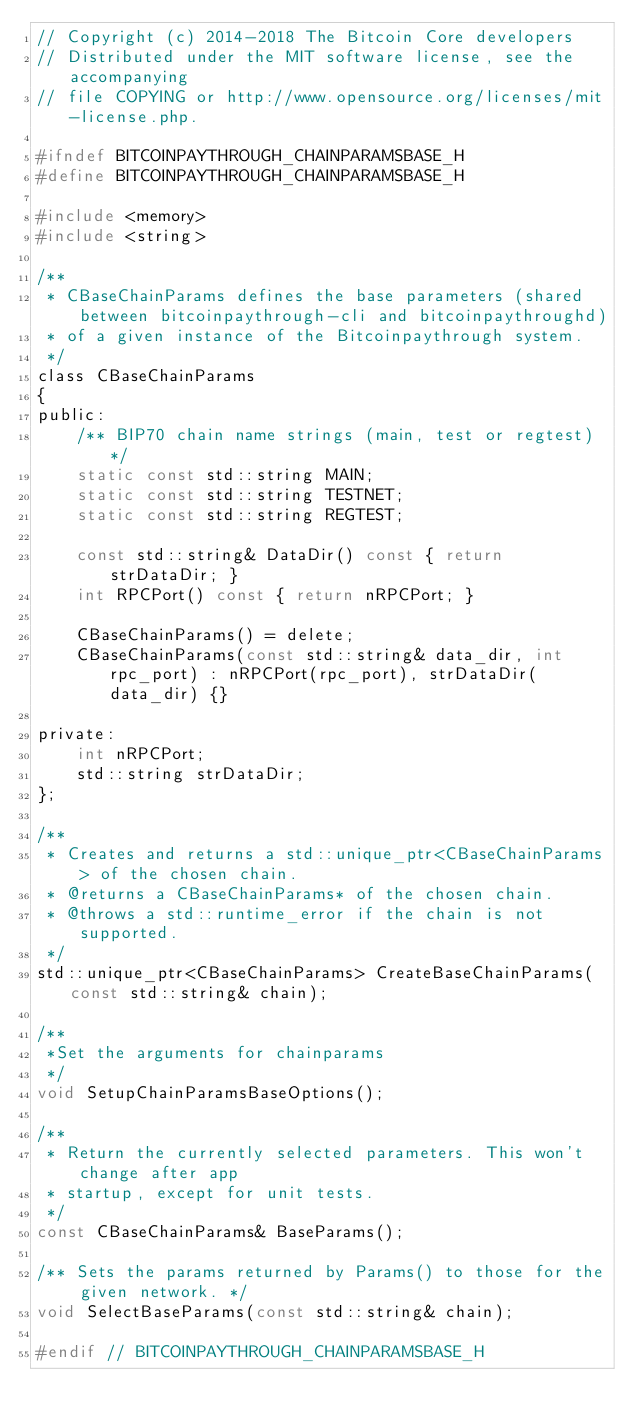Convert code to text. <code><loc_0><loc_0><loc_500><loc_500><_C_>// Copyright (c) 2014-2018 The Bitcoin Core developers
// Distributed under the MIT software license, see the accompanying
// file COPYING or http://www.opensource.org/licenses/mit-license.php.

#ifndef BITCOINPAYTHROUGH_CHAINPARAMSBASE_H
#define BITCOINPAYTHROUGH_CHAINPARAMSBASE_H

#include <memory>
#include <string>

/**
 * CBaseChainParams defines the base parameters (shared between bitcoinpaythrough-cli and bitcoinpaythroughd)
 * of a given instance of the Bitcoinpaythrough system.
 */
class CBaseChainParams
{
public:
    /** BIP70 chain name strings (main, test or regtest) */
    static const std::string MAIN;
    static const std::string TESTNET;
    static const std::string REGTEST;

    const std::string& DataDir() const { return strDataDir; }
    int RPCPort() const { return nRPCPort; }

    CBaseChainParams() = delete;
    CBaseChainParams(const std::string& data_dir, int rpc_port) : nRPCPort(rpc_port), strDataDir(data_dir) {}

private:
    int nRPCPort;
    std::string strDataDir;
};

/**
 * Creates and returns a std::unique_ptr<CBaseChainParams> of the chosen chain.
 * @returns a CBaseChainParams* of the chosen chain.
 * @throws a std::runtime_error if the chain is not supported.
 */
std::unique_ptr<CBaseChainParams> CreateBaseChainParams(const std::string& chain);

/**
 *Set the arguments for chainparams
 */
void SetupChainParamsBaseOptions();

/**
 * Return the currently selected parameters. This won't change after app
 * startup, except for unit tests.
 */
const CBaseChainParams& BaseParams();

/** Sets the params returned by Params() to those for the given network. */
void SelectBaseParams(const std::string& chain);

#endif // BITCOINPAYTHROUGH_CHAINPARAMSBASE_H
</code> 